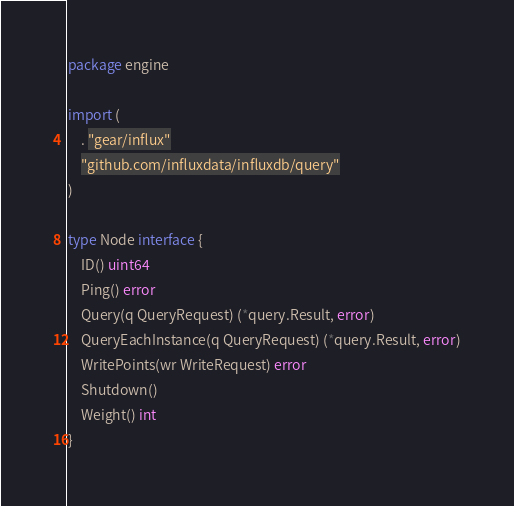Convert code to text. <code><loc_0><loc_0><loc_500><loc_500><_Go_>package engine

import (
	. "gear/influx"
	"github.com/influxdata/influxdb/query"
)

type Node interface {
	ID() uint64
	Ping() error
	Query(q QueryRequest) (*query.Result, error)
	QueryEachInstance(q QueryRequest) (*query.Result, error)
	WritePoints(wr WriteRequest) error
	Shutdown()
	Weight() int
}
</code> 